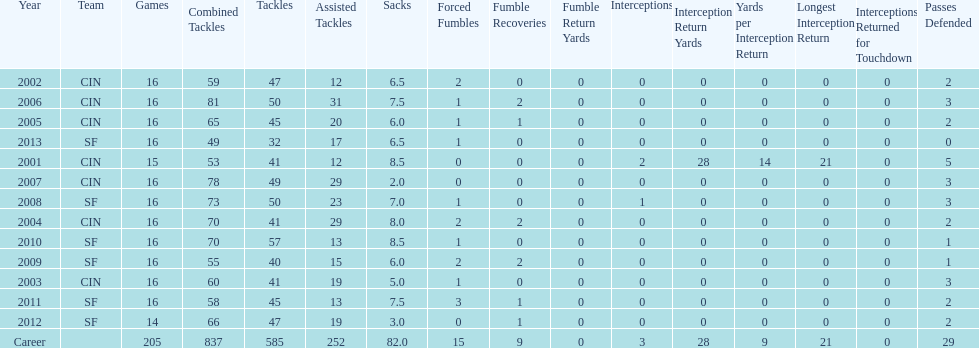How many sacks did this player have in his first five seasons? 34. 